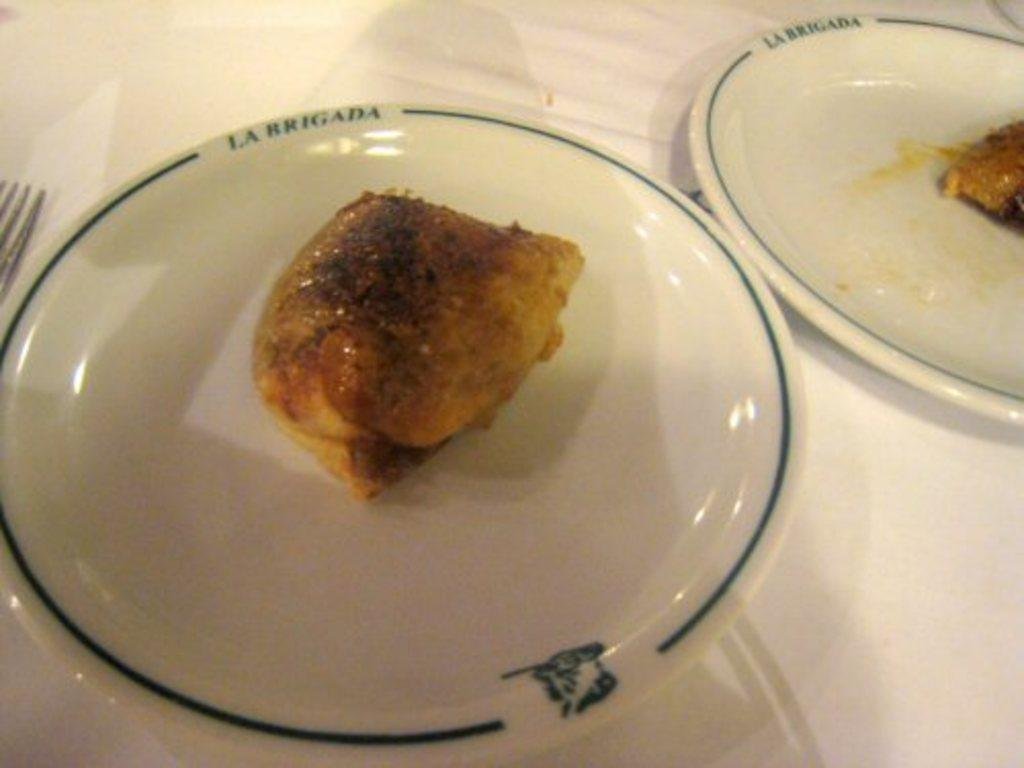What type of items can be seen in the image? There are food items in the image. How are the food items arranged or placed? The food items are in plates. What utensils are present in the image? There are forks on a platform in the image. How many maids are attending to the food items in the image? There are no maids present in the image. Are there any ants visible on the food items in the image? There is no indication of ants on the food items in the image. 